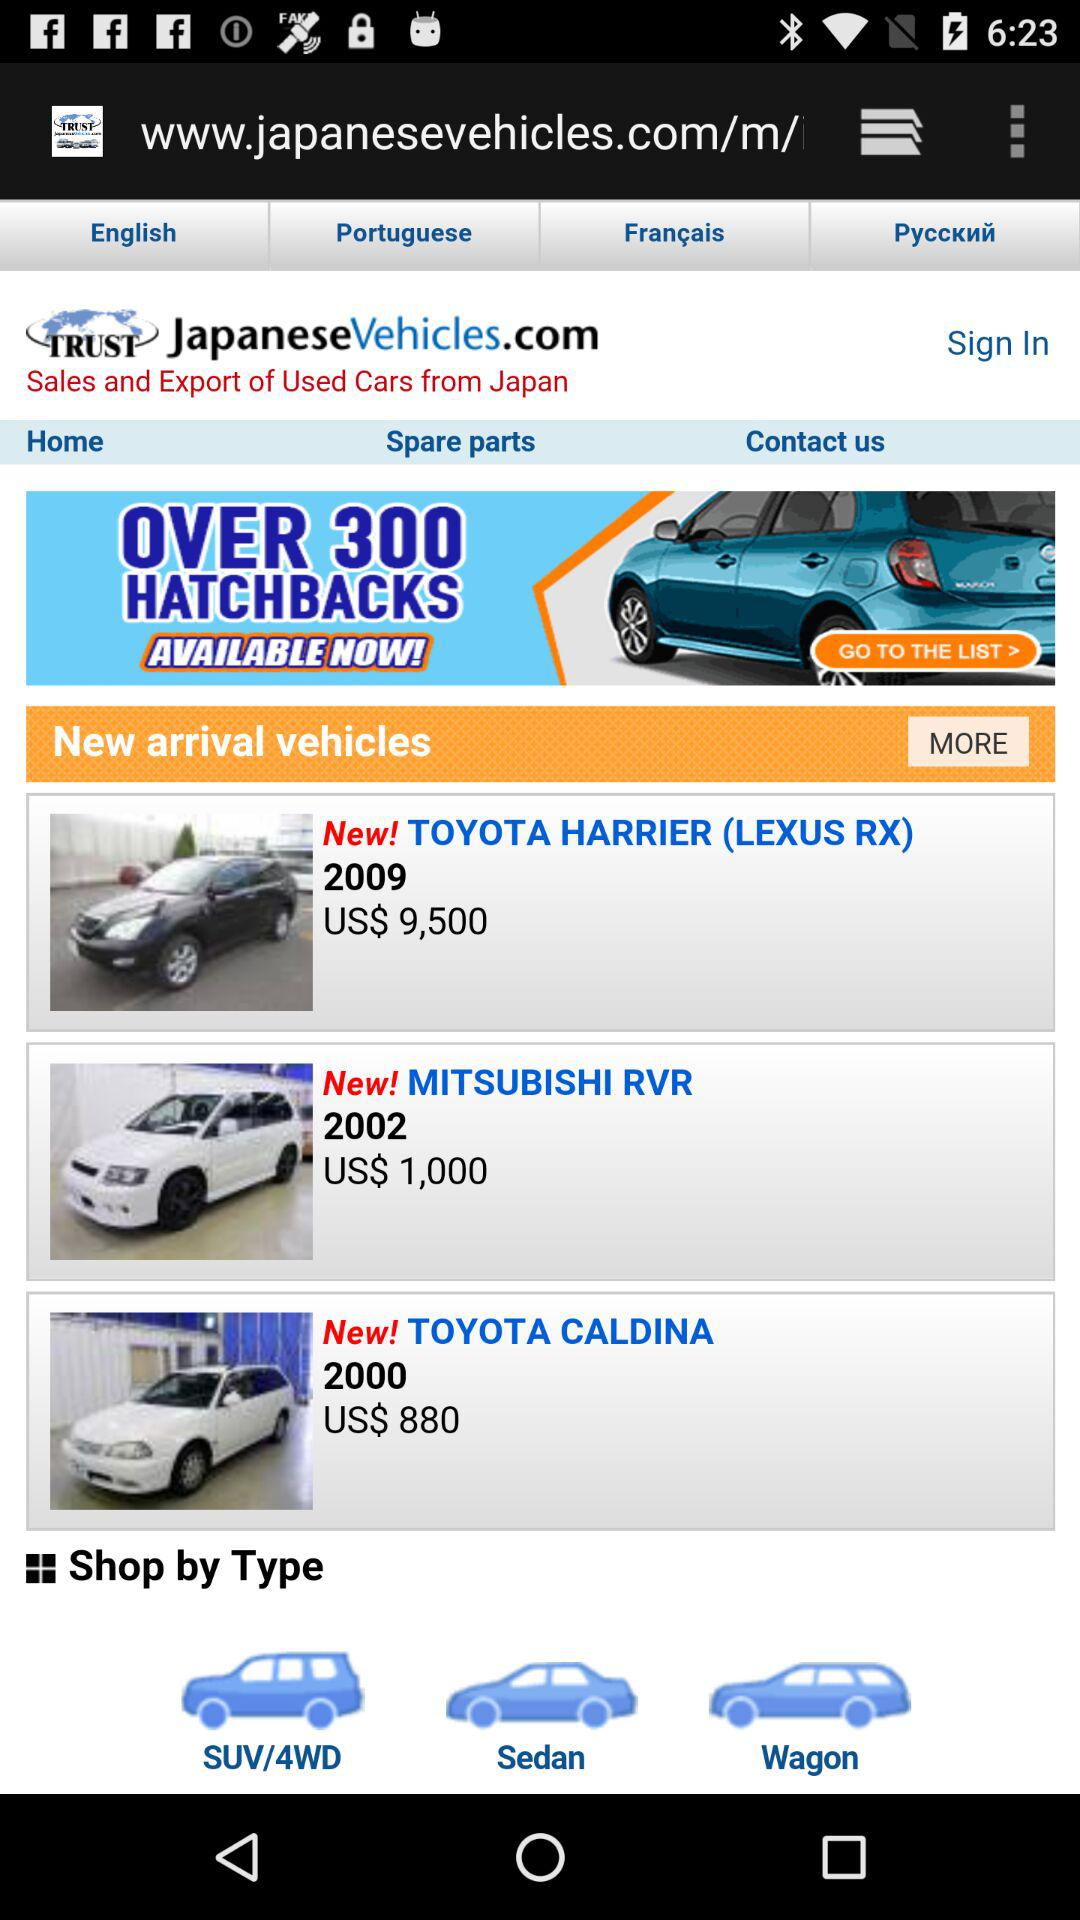What is the model number and price of the Toyota caldina? The model number is 2000, and the price is US$ 880. 